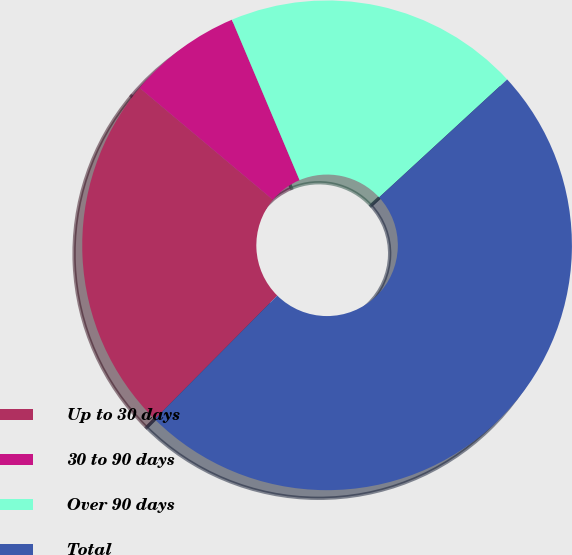Convert chart. <chart><loc_0><loc_0><loc_500><loc_500><pie_chart><fcel>Up to 30 days<fcel>30 to 90 days<fcel>Over 90 days<fcel>Total<nl><fcel>23.69%<fcel>7.53%<fcel>19.51%<fcel>49.27%<nl></chart> 